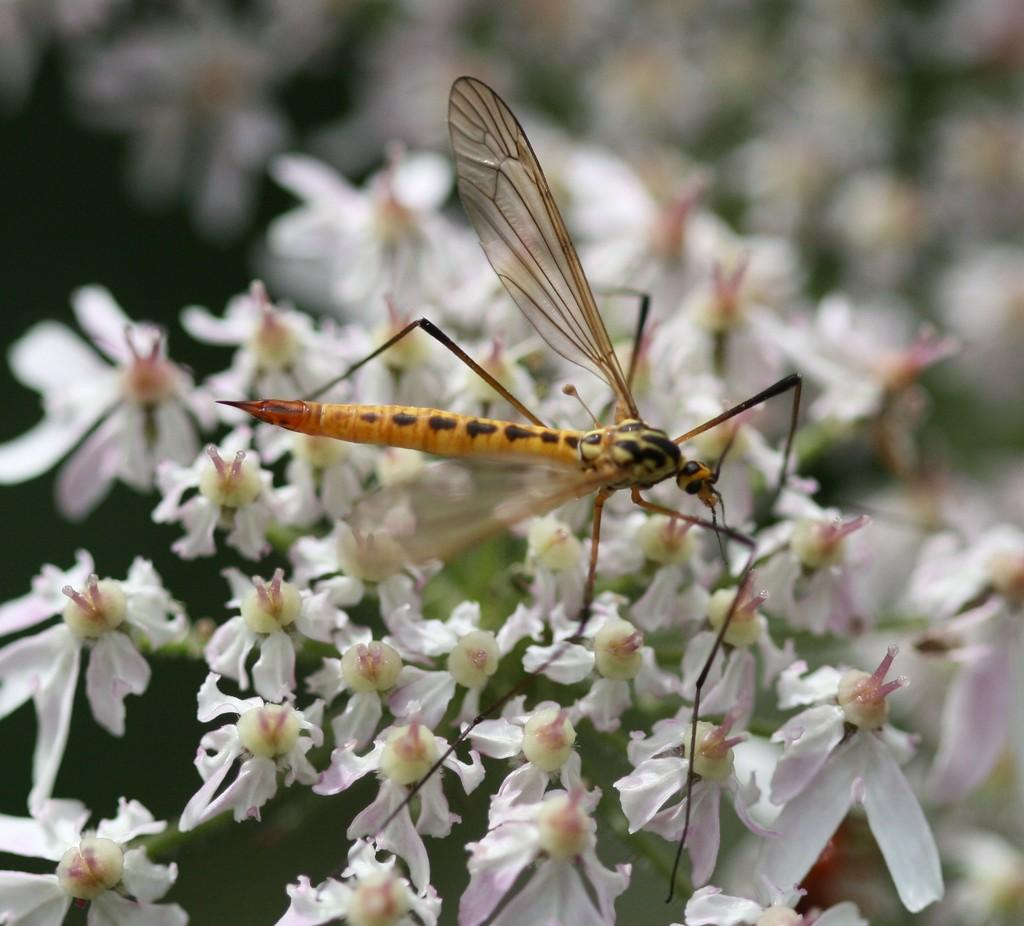What is present in the image? There is a fly in the image. What is the fly sitting on? The fly is on white color flowers. Can you see the ocean in the image? No, the ocean is not present in the image; it only features a fly on white color flowers. 